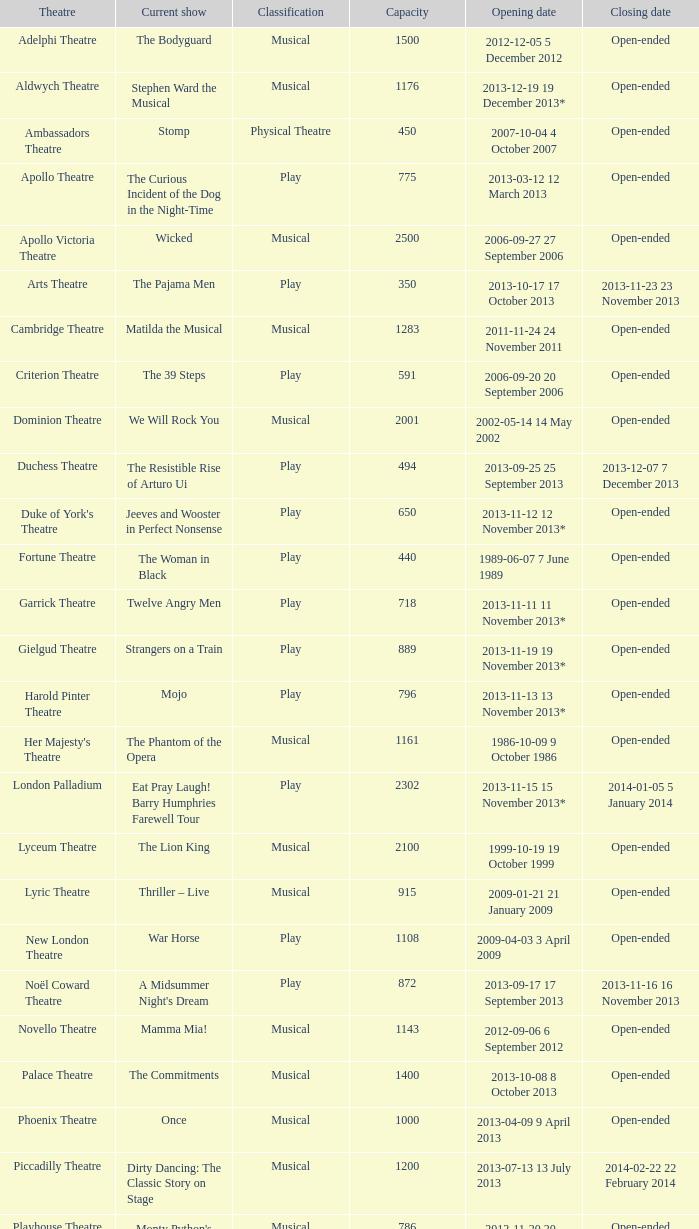When is the opening day with a 100-person capacity? 2013-11-01 1 November 2013. 